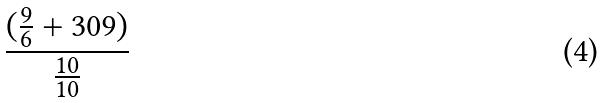<formula> <loc_0><loc_0><loc_500><loc_500>\frac { ( \frac { 9 } { 6 } + 3 0 9 ) } { \frac { 1 0 } { 1 0 } }</formula> 